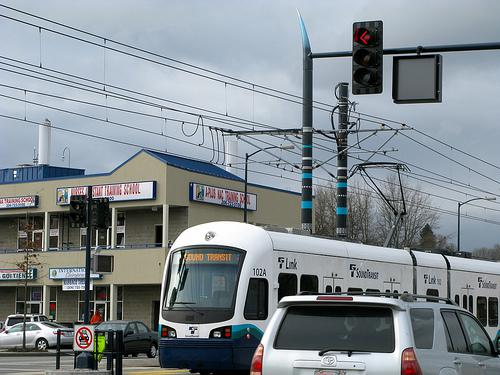Question: what is behind the train?
Choices:
A. Building.
B. Barn.
C. Church.
D. Store.
Answer with the letter. Answer: A 